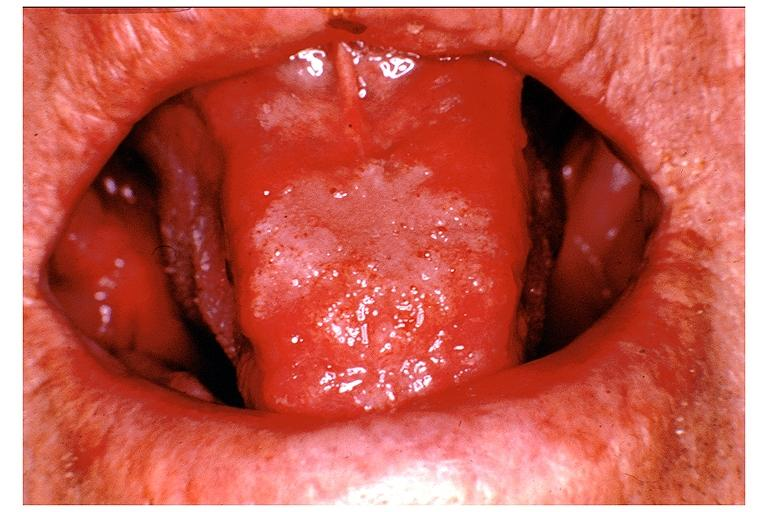does this typical lesion show blastomycosis?
Answer the question using a single word or phrase. No 